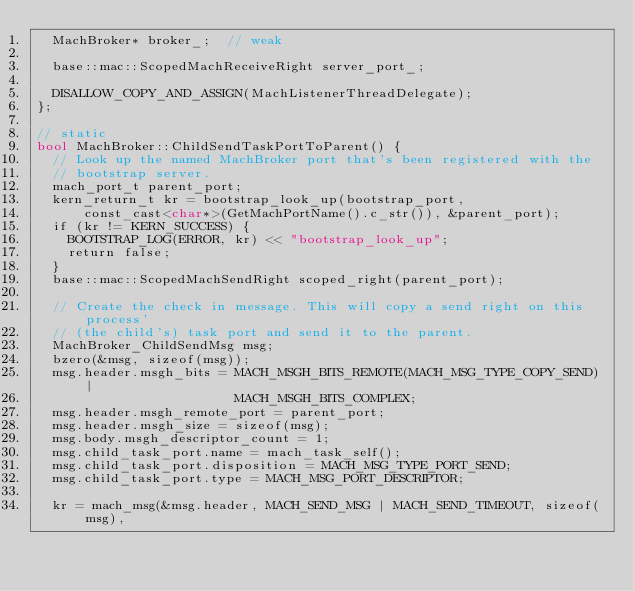Convert code to text. <code><loc_0><loc_0><loc_500><loc_500><_ObjectiveC_>  MachBroker* broker_;  // weak

  base::mac::ScopedMachReceiveRight server_port_;

  DISALLOW_COPY_AND_ASSIGN(MachListenerThreadDelegate);
};

// static
bool MachBroker::ChildSendTaskPortToParent() {
  // Look up the named MachBroker port that's been registered with the
  // bootstrap server.
  mach_port_t parent_port;
  kern_return_t kr = bootstrap_look_up(bootstrap_port,
      const_cast<char*>(GetMachPortName().c_str()), &parent_port);
  if (kr != KERN_SUCCESS) {
    BOOTSTRAP_LOG(ERROR, kr) << "bootstrap_look_up";
    return false;
  }
  base::mac::ScopedMachSendRight scoped_right(parent_port);

  // Create the check in message. This will copy a send right on this process'
  // (the child's) task port and send it to the parent.
  MachBroker_ChildSendMsg msg;
  bzero(&msg, sizeof(msg));
  msg.header.msgh_bits = MACH_MSGH_BITS_REMOTE(MACH_MSG_TYPE_COPY_SEND) |
                         MACH_MSGH_BITS_COMPLEX;
  msg.header.msgh_remote_port = parent_port;
  msg.header.msgh_size = sizeof(msg);
  msg.body.msgh_descriptor_count = 1;
  msg.child_task_port.name = mach_task_self();
  msg.child_task_port.disposition = MACH_MSG_TYPE_PORT_SEND;
  msg.child_task_port.type = MACH_MSG_PORT_DESCRIPTOR;

  kr = mach_msg(&msg.header, MACH_SEND_MSG | MACH_SEND_TIMEOUT, sizeof(msg),</code> 